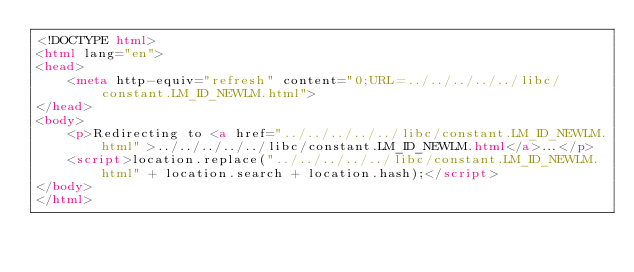Convert code to text. <code><loc_0><loc_0><loc_500><loc_500><_HTML_><!DOCTYPE html>
<html lang="en">
<head>
    <meta http-equiv="refresh" content="0;URL=../../../../../libc/constant.LM_ID_NEWLM.html">
</head>
<body>
    <p>Redirecting to <a href="../../../../../libc/constant.LM_ID_NEWLM.html">../../../../../libc/constant.LM_ID_NEWLM.html</a>...</p>
    <script>location.replace("../../../../../libc/constant.LM_ID_NEWLM.html" + location.search + location.hash);</script>
</body>
</html></code> 